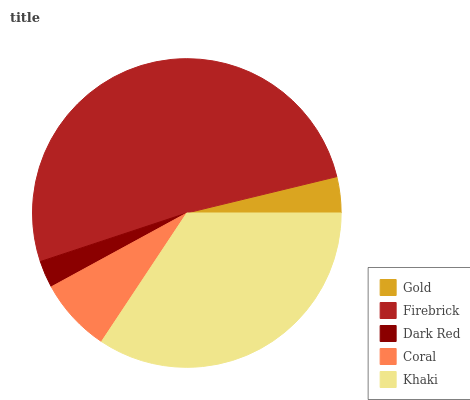Is Dark Red the minimum?
Answer yes or no. Yes. Is Firebrick the maximum?
Answer yes or no. Yes. Is Firebrick the minimum?
Answer yes or no. No. Is Dark Red the maximum?
Answer yes or no. No. Is Firebrick greater than Dark Red?
Answer yes or no. Yes. Is Dark Red less than Firebrick?
Answer yes or no. Yes. Is Dark Red greater than Firebrick?
Answer yes or no. No. Is Firebrick less than Dark Red?
Answer yes or no. No. Is Coral the high median?
Answer yes or no. Yes. Is Coral the low median?
Answer yes or no. Yes. Is Dark Red the high median?
Answer yes or no. No. Is Gold the low median?
Answer yes or no. No. 